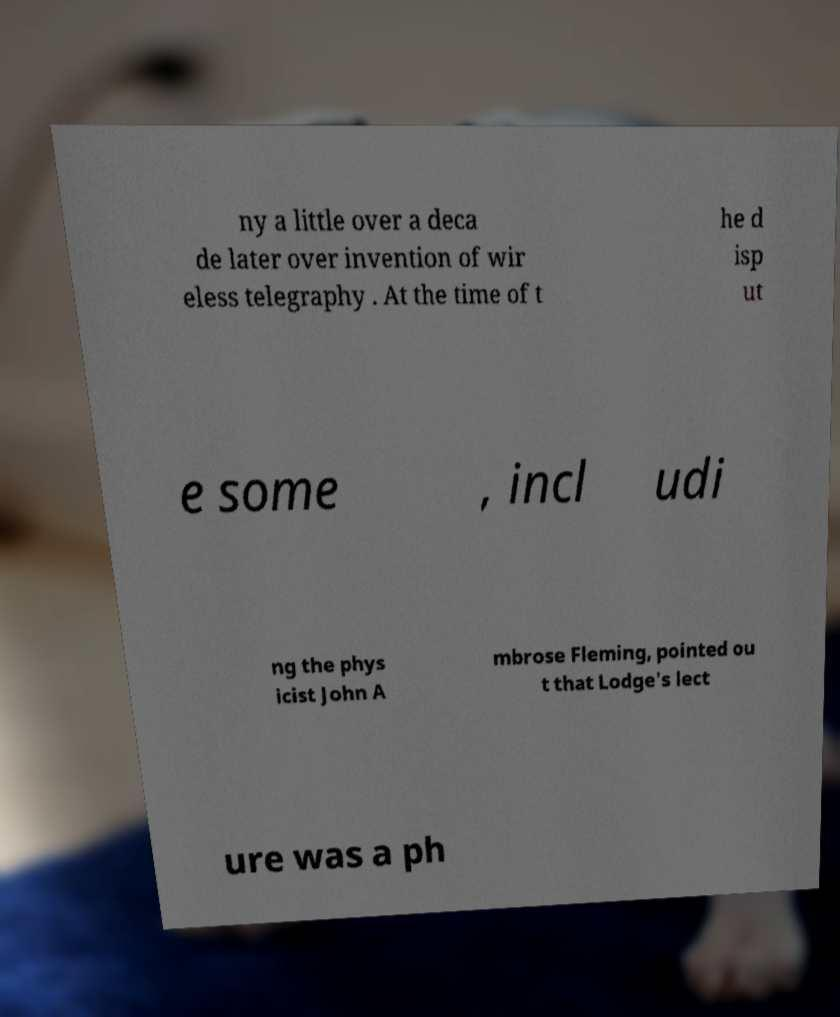Can you read and provide the text displayed in the image?This photo seems to have some interesting text. Can you extract and type it out for me? ny a little over a deca de later over invention of wir eless telegraphy . At the time of t he d isp ut e some , incl udi ng the phys icist John A mbrose Fleming, pointed ou t that Lodge's lect ure was a ph 